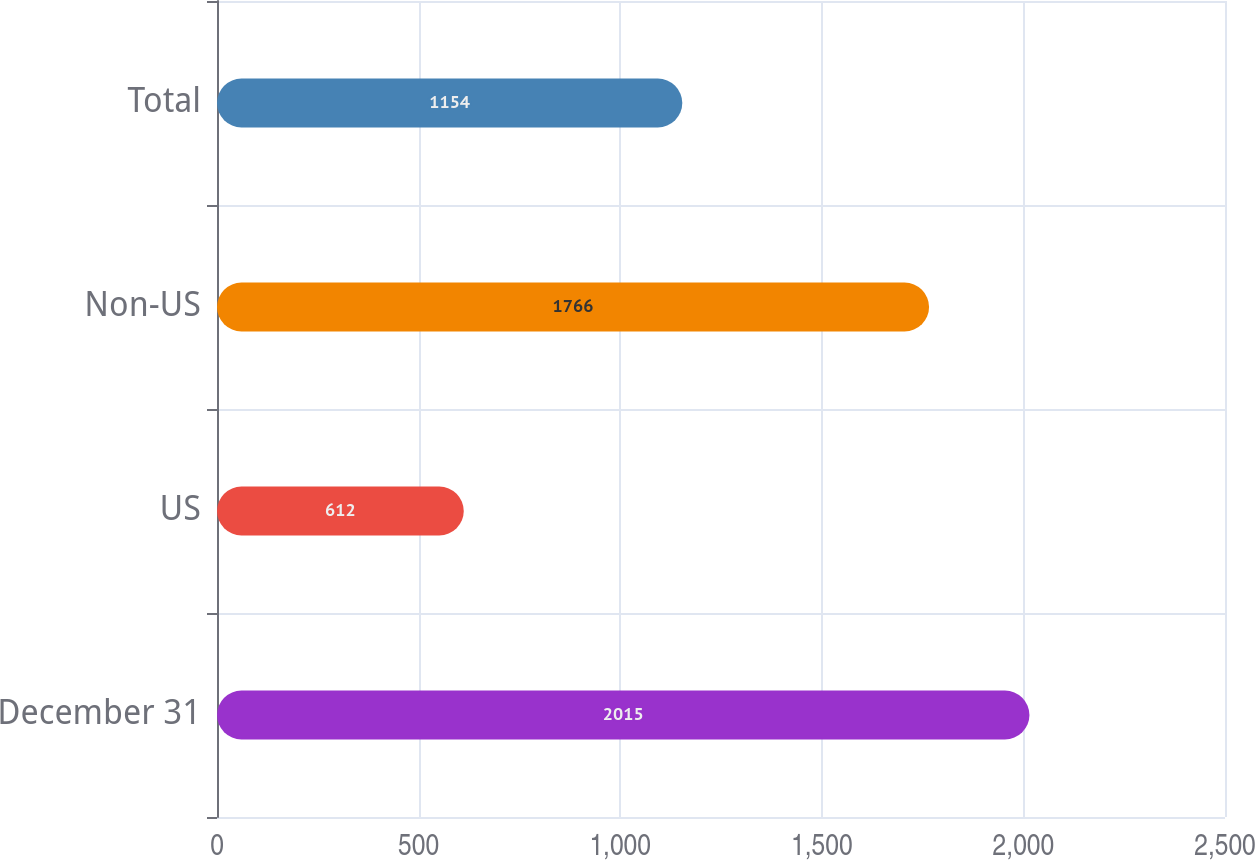Convert chart to OTSL. <chart><loc_0><loc_0><loc_500><loc_500><bar_chart><fcel>December 31<fcel>US<fcel>Non-US<fcel>Total<nl><fcel>2015<fcel>612<fcel>1766<fcel>1154<nl></chart> 